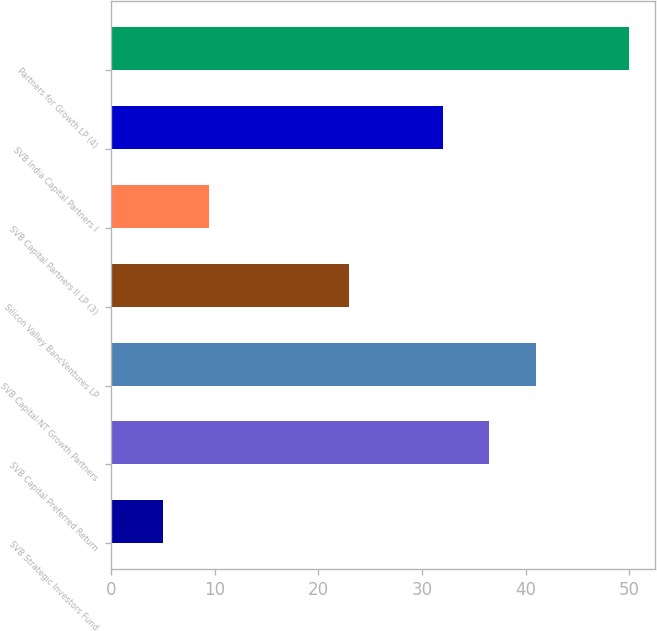<chart> <loc_0><loc_0><loc_500><loc_500><bar_chart><fcel>SVB Strategic Investors Fund<fcel>SVB Capital Preferred Return<fcel>SVB Capital-NT Growth Partners<fcel>Silicon Valley BancVentures LP<fcel>SVB Capital Partners II LP (3)<fcel>SVB India Capital Partners I<fcel>Partners for Growth LP (4)<nl><fcel>5<fcel>36.5<fcel>41<fcel>23<fcel>9.5<fcel>32<fcel>50<nl></chart> 